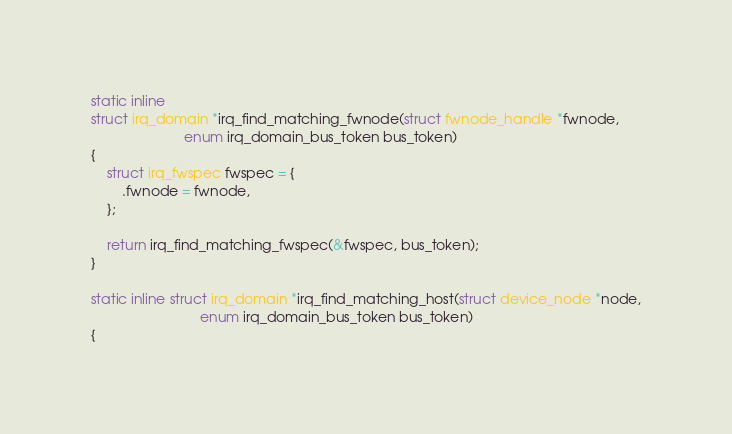Convert code to text. <code><loc_0><loc_0><loc_500><loc_500><_C_>
static inline
struct irq_domain *irq_find_matching_fwnode(struct fwnode_handle *fwnode,
					    enum irq_domain_bus_token bus_token)
{
	struct irq_fwspec fwspec = {
		.fwnode = fwnode,
	};

	return irq_find_matching_fwspec(&fwspec, bus_token);
}

static inline struct irq_domain *irq_find_matching_host(struct device_node *node,
							enum irq_domain_bus_token bus_token)
{</code> 